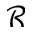Convert formula to latex. <formula><loc_0><loc_0><loc_500><loc_500>\mathcal { R }</formula> 